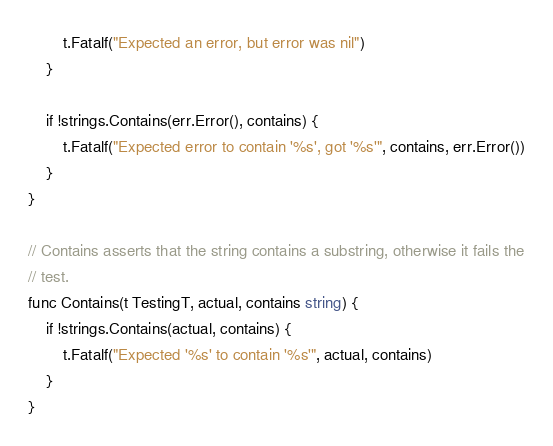<code> <loc_0><loc_0><loc_500><loc_500><_Go_>		t.Fatalf("Expected an error, but error was nil")
	}

	if !strings.Contains(err.Error(), contains) {
		t.Fatalf("Expected error to contain '%s', got '%s'", contains, err.Error())
	}
}

// Contains asserts that the string contains a substring, otherwise it fails the
// test.
func Contains(t TestingT, actual, contains string) {
	if !strings.Contains(actual, contains) {
		t.Fatalf("Expected '%s' to contain '%s'", actual, contains)
	}
}
</code> 